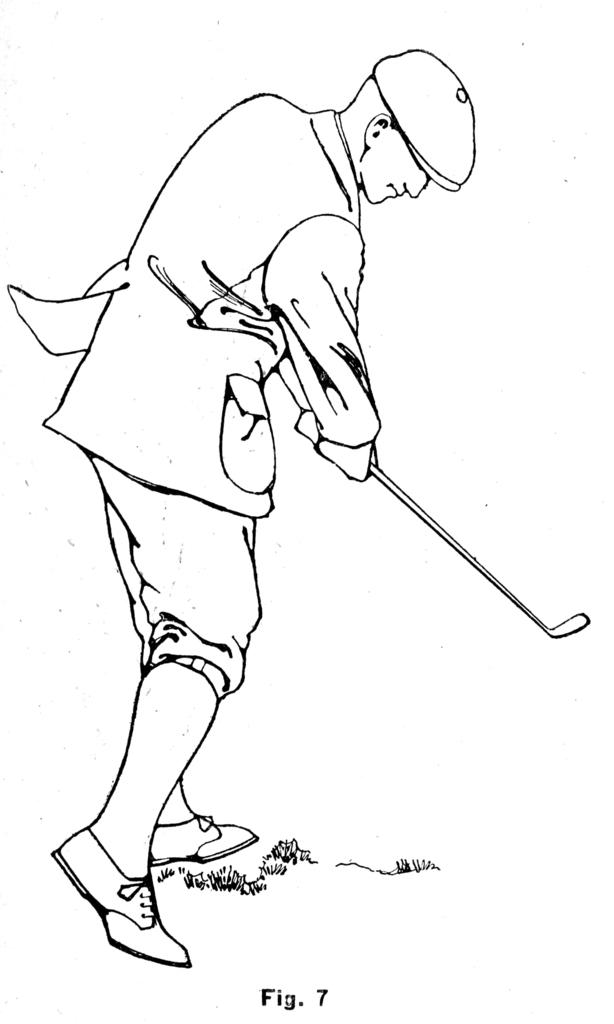What is depicted in the image? There is a drawing in the image. Can you describe the content of the drawing? A man is standing in the drawing, and he is holding a stick. What is the color of the background in the drawing? The background of the drawing is white. What type of toothpaste is the man using in the drawing? There is no toothpaste present in the drawing; the man is holding a stick. What kind of tools might a zebra need to perform the carpenter's job in the drawing? There is no zebra or carpenter in the drawing; it features a man holding a stick in a white background. 